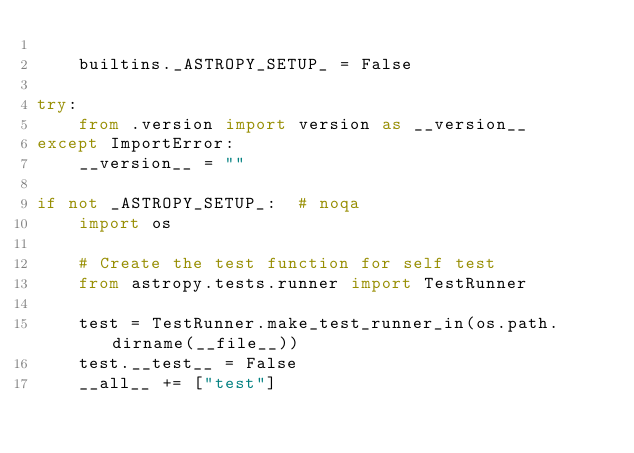<code> <loc_0><loc_0><loc_500><loc_500><_Python_>
    builtins._ASTROPY_SETUP_ = False

try:
    from .version import version as __version__
except ImportError:
    __version__ = ""

if not _ASTROPY_SETUP_:  # noqa
    import os

    # Create the test function for self test
    from astropy.tests.runner import TestRunner

    test = TestRunner.make_test_runner_in(os.path.dirname(__file__))
    test.__test__ = False
    __all__ += ["test"]
</code> 